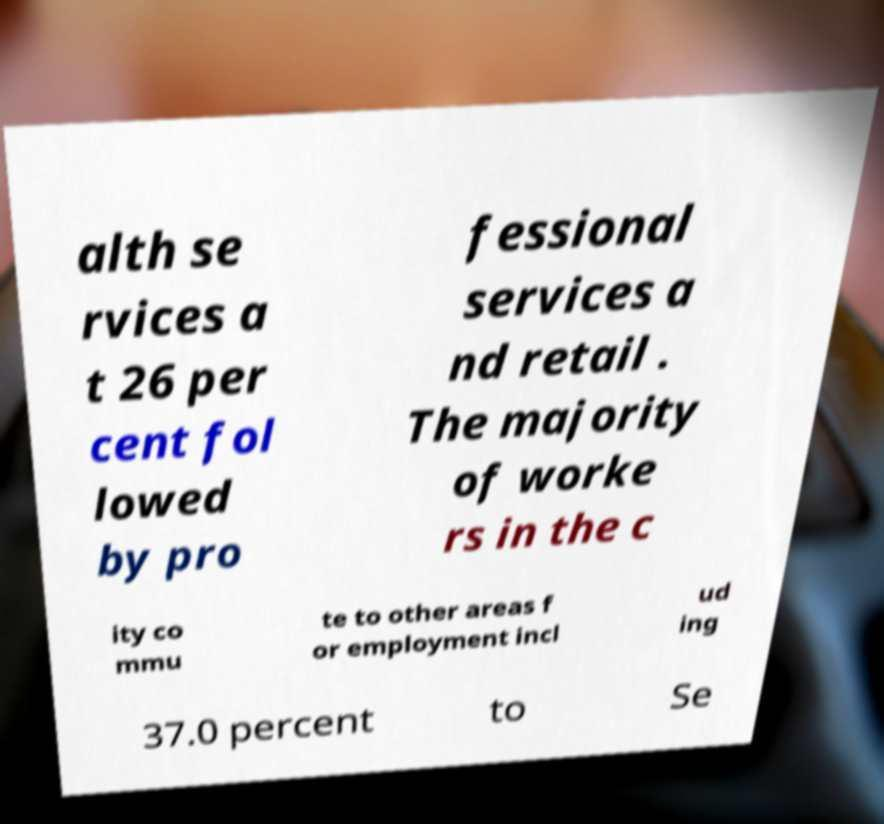Can you accurately transcribe the text from the provided image for me? alth se rvices a t 26 per cent fol lowed by pro fessional services a nd retail . The majority of worke rs in the c ity co mmu te to other areas f or employment incl ud ing 37.0 percent to Se 